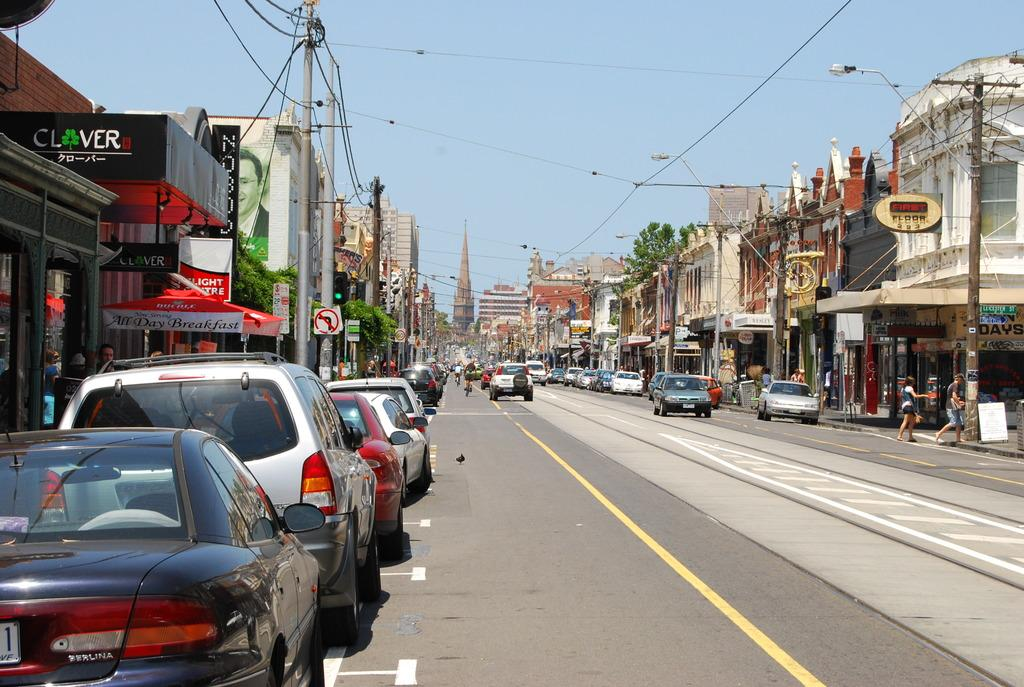<image>
Describe the image concisely. A street lined with cars has signs for shops such as Clover and First floor along the road. 